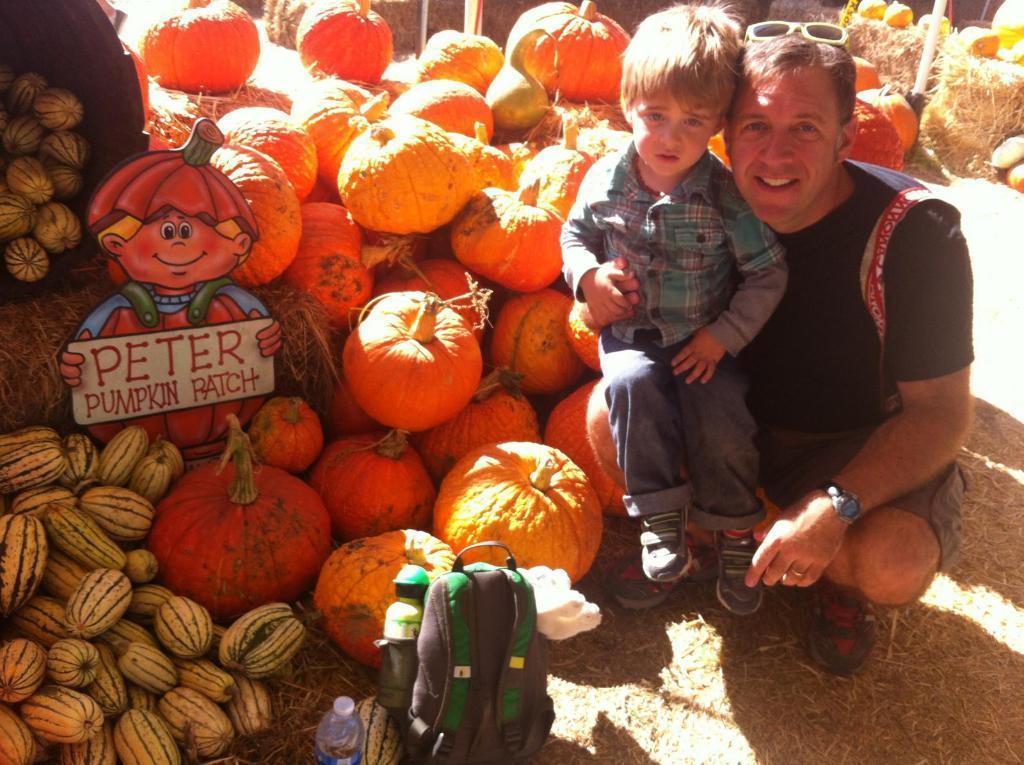In one or two sentences, can you explain what this image depicts? In this image I can see a boy and a man. I can also see number of pumpkins, a bag and few bottles. I can also see something is written over there and here I can see specs on his head. I can also see shadows on ground. 